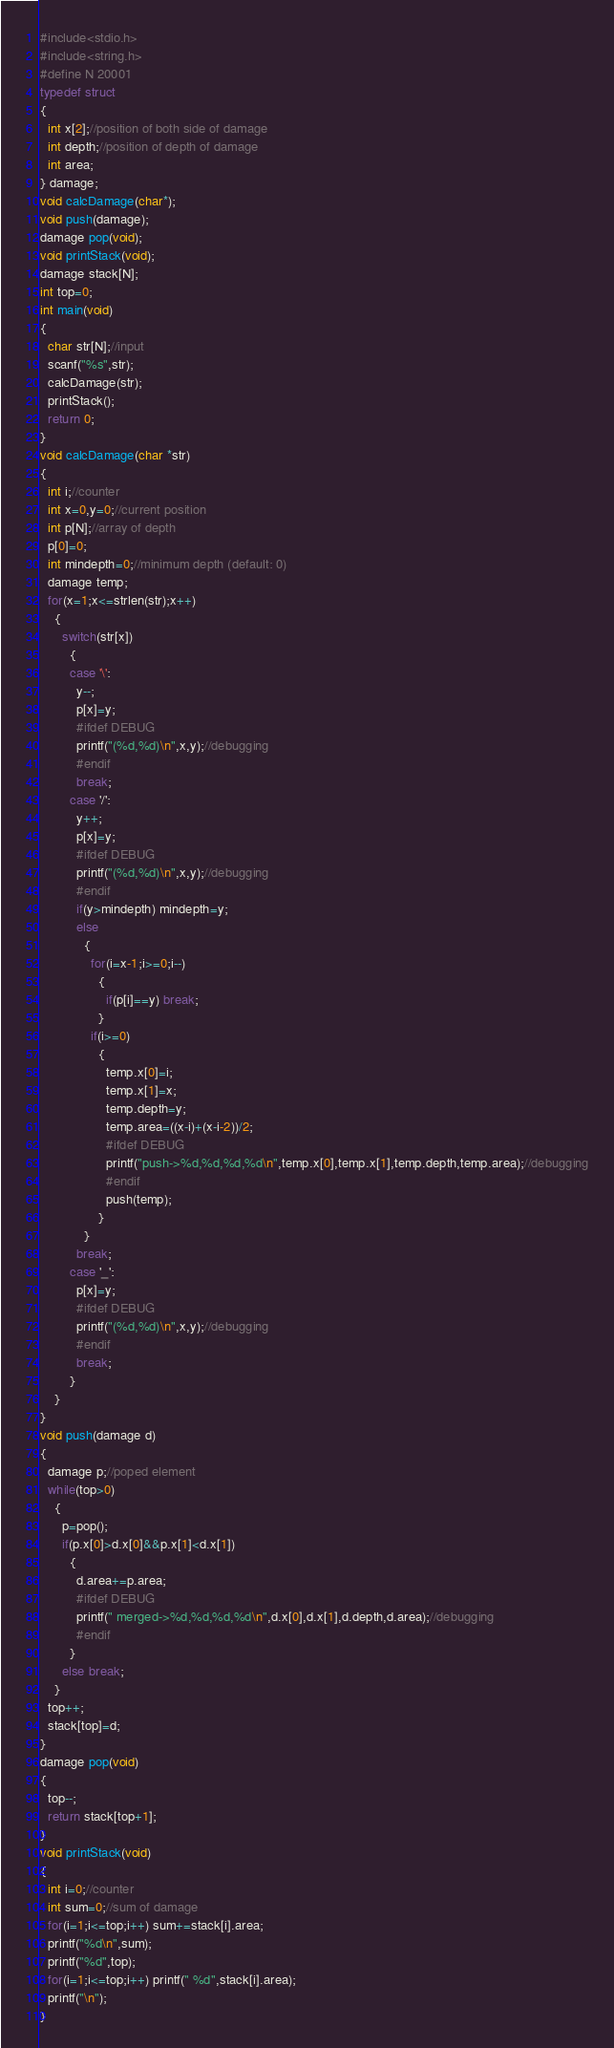<code> <loc_0><loc_0><loc_500><loc_500><_C_>#include<stdio.h>
#include<string.h>
#define N 20001
typedef struct
{
  int x[2];//position of both side of damage
  int depth;//position of depth of damage
  int area;
} damage;
void calcDamage(char*);
void push(damage);
damage pop(void);
void printStack(void);
damage stack[N];
int top=0;
int main(void)
{
  char str[N];//input
  scanf("%s",str);
  calcDamage(str);
  printStack();
  return 0;
}
void calcDamage(char *str)
{
  int i;//counter
  int x=0,y=0;//current position
  int p[N];//array of depth
  p[0]=0;
  int mindepth=0;//minimum depth (default: 0)
  damage temp;
  for(x=1;x<=strlen(str);x++)
    {
      switch(str[x])
        {
        case '\':
          y--;
          p[x]=y;
          #ifdef DEBUG
          printf("(%d,%d)\n",x,y);//debugging
          #endif
          break;
        case '/':
          y++;
          p[x]=y;
          #ifdef DEBUG
          printf("(%d,%d)\n",x,y);//debugging
          #endif
          if(y>mindepth) mindepth=y;
          else
            {
              for(i=x-1;i>=0;i--)
                {
                  if(p[i]==y) break;
                }
              if(i>=0)
                {
                  temp.x[0]=i;
                  temp.x[1]=x;
                  temp.depth=y;
                  temp.area=((x-i)+(x-i-2))/2;
                  #ifdef DEBUG
                  printf("push->%d,%d,%d,%d\n",temp.x[0],temp.x[1],temp.depth,temp.area);//debugging
                  #endif
                  push(temp);
                }
            }
          break;
        case '_':
          p[x]=y;
          #ifdef DEBUG
          printf("(%d,%d)\n",x,y);//debugging
          #endif
          break;
        }
    }
}
void push(damage d)
{
  damage p;//poped element
  while(top>0)
    {
      p=pop();
      if(p.x[0]>d.x[0]&&p.x[1]<d.x[1])
        {
          d.area+=p.area;
          #ifdef DEBUG
          printf(" merged->%d,%d,%d,%d\n",d.x[0],d.x[1],d.depth,d.area);//debugging
          #endif
        }
      else break;
    }
  top++;
  stack[top]=d;
}
damage pop(void)
{
  top--;
  return stack[top+1];
}
void printStack(void)
{
  int i=0;//counter
  int sum=0;//sum of damage
  for(i=1;i<=top;i++) sum+=stack[i].area;
  printf("%d\n",sum);
  printf("%d",top);
  for(i=1;i<=top;i++) printf(" %d",stack[i].area);
  printf("\n");
}
</code> 